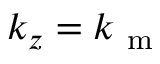Convert formula to latex. <formula><loc_0><loc_0><loc_500><loc_500>k _ { z } = k _ { m }</formula> 